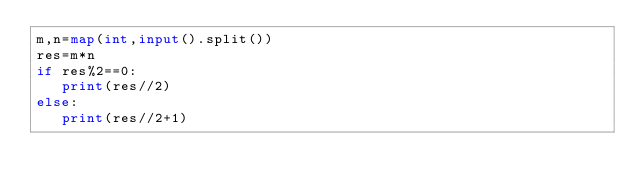<code> <loc_0><loc_0><loc_500><loc_500><_Python_>m,n=map(int,input().split())
res=m*n
if res%2==0:
   print(res//2)
else:
   print(res//2+1)
</code> 